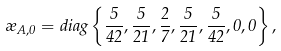Convert formula to latex. <formula><loc_0><loc_0><loc_500><loc_500>\rho _ { A , 0 } = d i a g \left \{ \frac { 5 } { 4 2 } , \frac { 5 } { 2 1 } , \frac { 2 } { 7 } , \frac { 5 } { 2 1 } , \frac { 5 } { 4 2 } , 0 , 0 \right \} ,</formula> 